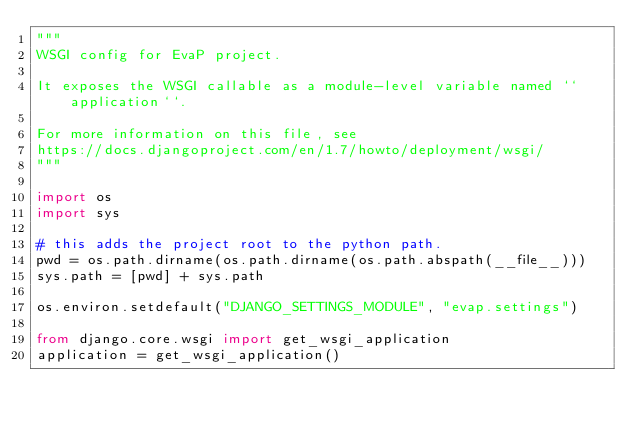<code> <loc_0><loc_0><loc_500><loc_500><_Python_>"""
WSGI config for EvaP project.

It exposes the WSGI callable as a module-level variable named ``application``.

For more information on this file, see
https://docs.djangoproject.com/en/1.7/howto/deployment/wsgi/
"""

import os
import sys

# this adds the project root to the python path.
pwd = os.path.dirname(os.path.dirname(os.path.abspath(__file__)))
sys.path = [pwd] + sys.path

os.environ.setdefault("DJANGO_SETTINGS_MODULE", "evap.settings")

from django.core.wsgi import get_wsgi_application
application = get_wsgi_application()
</code> 